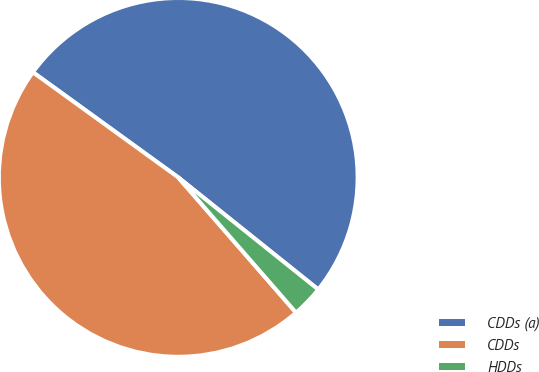Convert chart. <chart><loc_0><loc_0><loc_500><loc_500><pie_chart><fcel>CDDs (a)<fcel>CDDs<fcel>HDDs<nl><fcel>50.78%<fcel>46.38%<fcel>2.85%<nl></chart> 